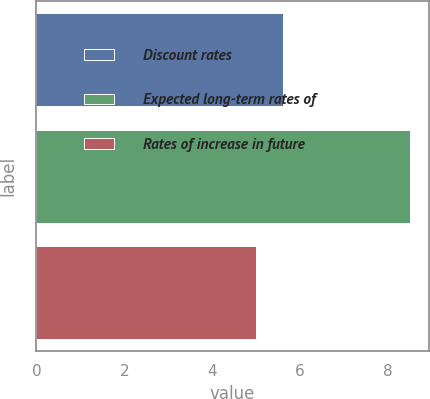Convert chart to OTSL. <chart><loc_0><loc_0><loc_500><loc_500><bar_chart><fcel>Discount rates<fcel>Expected long-term rates of<fcel>Rates of increase in future<nl><fcel>5.62<fcel>8.5<fcel>5<nl></chart> 